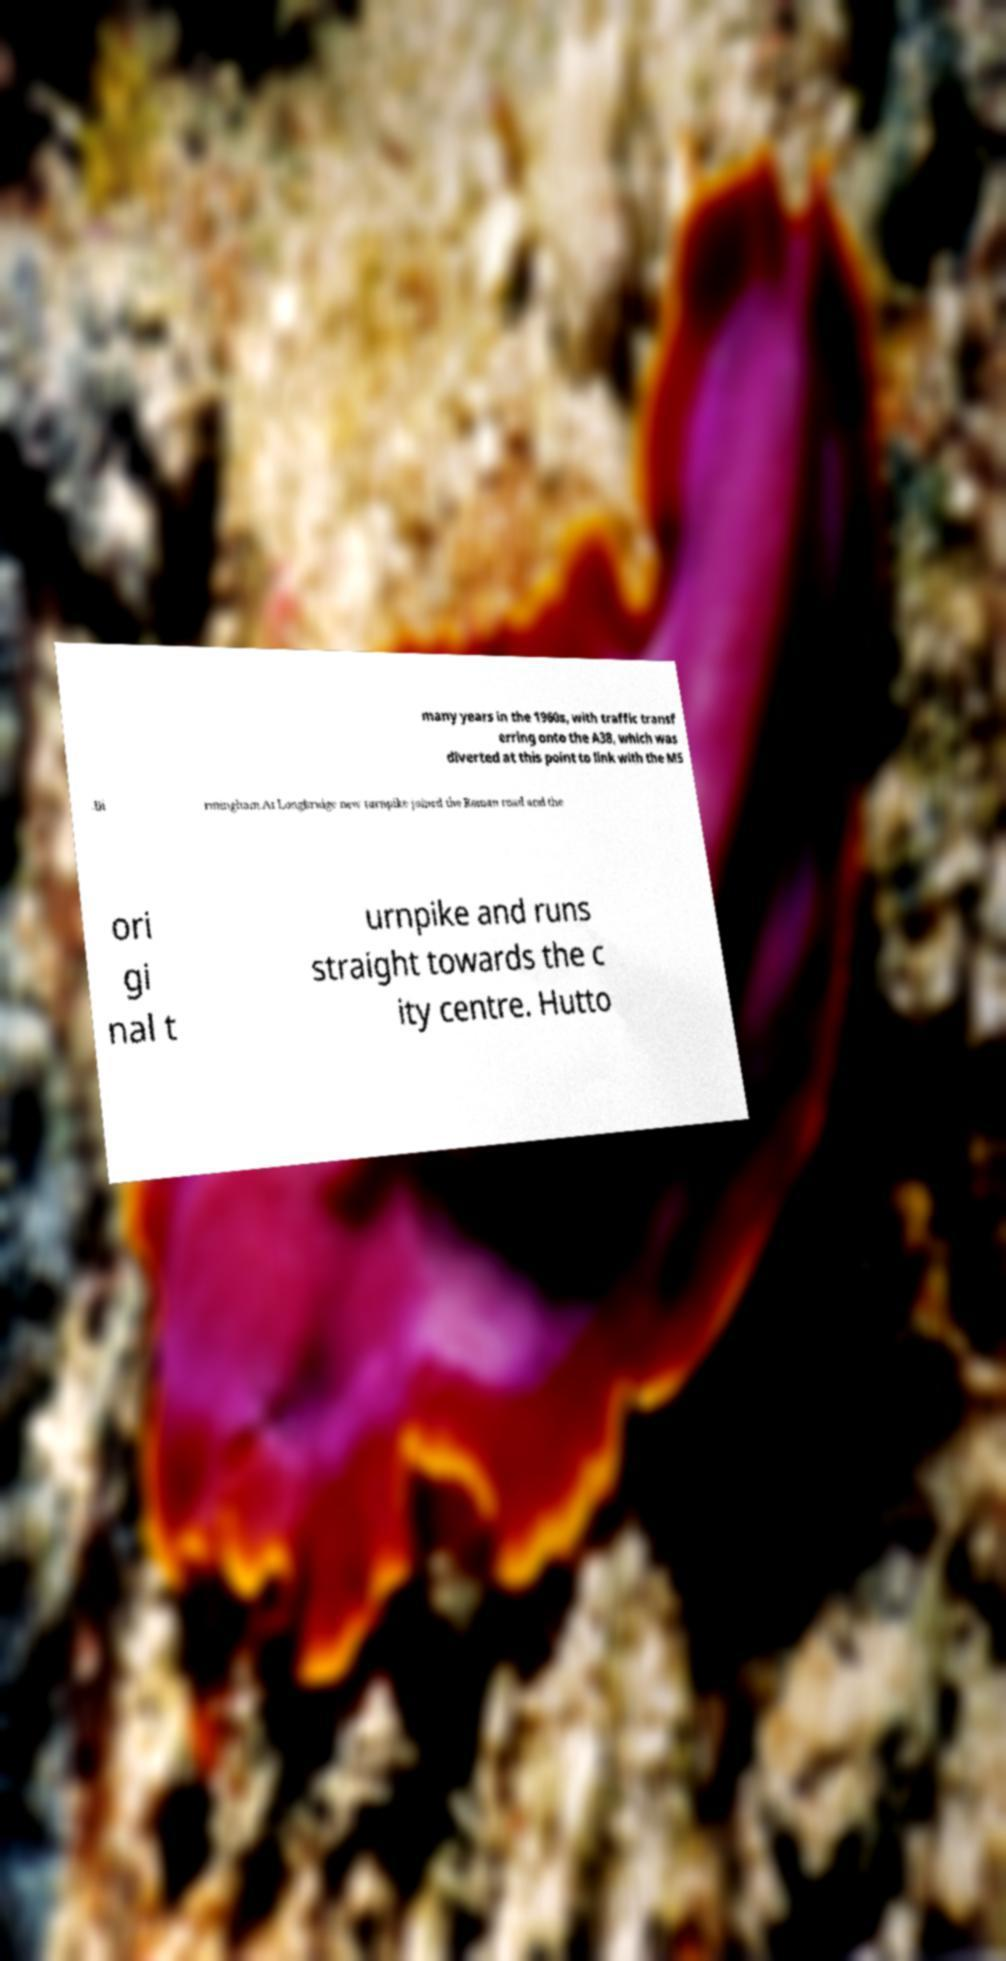Can you accurately transcribe the text from the provided image for me? many years in the 1960s, with traffic transf erring onto the A38, which was diverted at this point to link with the M5 .Bi rmingham.At Longbridge new turnpike joined the Roman road and the ori gi nal t urnpike and runs straight towards the c ity centre. Hutto 